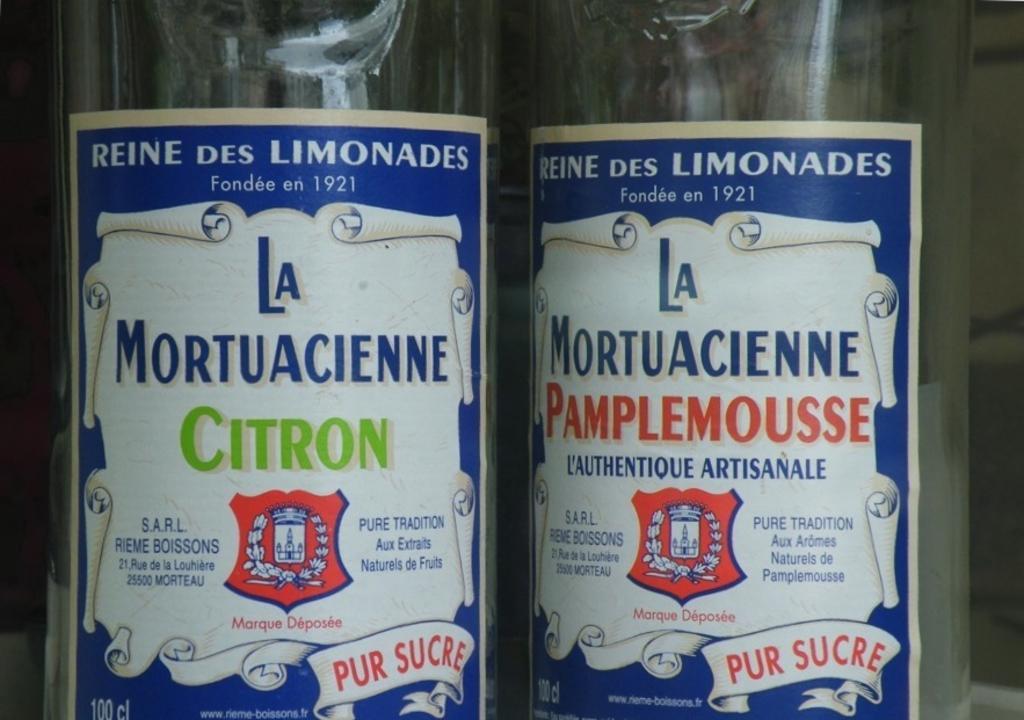In one or two sentences, can you explain what this image depicts? There are two bottles with the labels on it. 